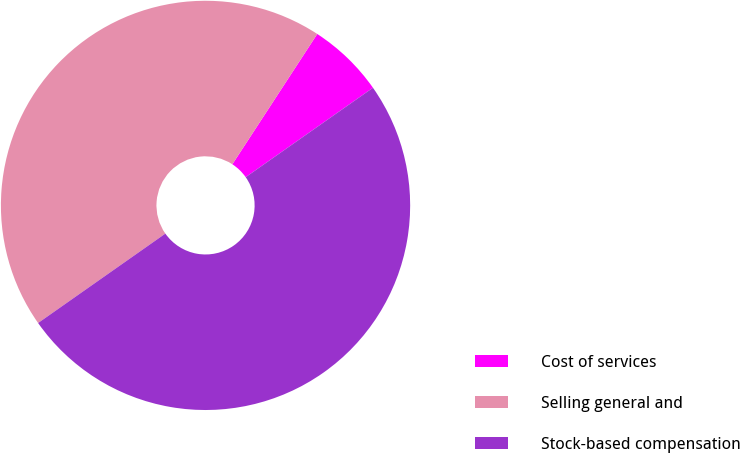Convert chart. <chart><loc_0><loc_0><loc_500><loc_500><pie_chart><fcel>Cost of services<fcel>Selling general and<fcel>Stock-based compensation<nl><fcel>6.06%<fcel>43.94%<fcel>50.0%<nl></chart> 